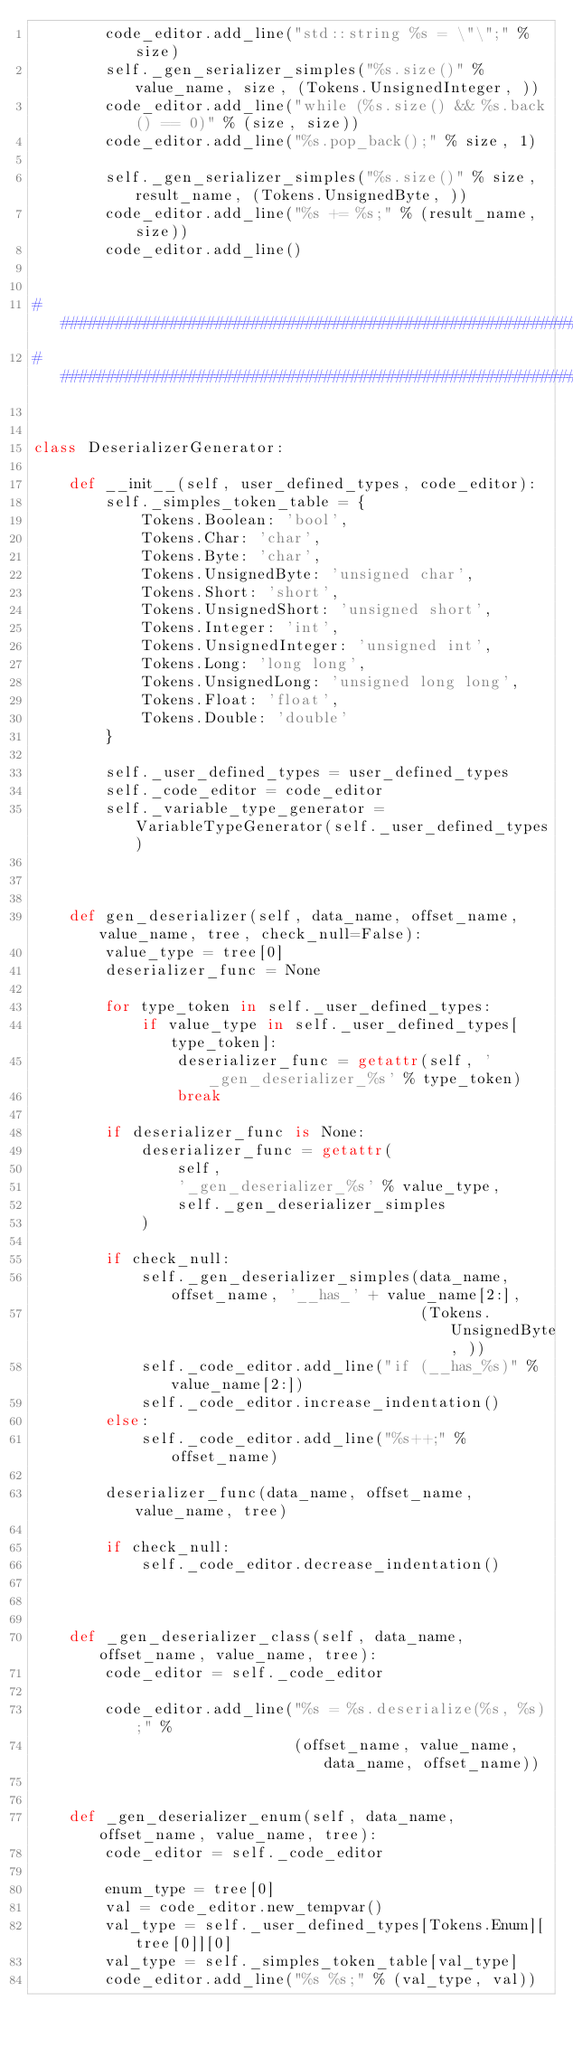<code> <loc_0><loc_0><loc_500><loc_500><_Python_>        code_editor.add_line("std::string %s = \"\";" % size)
        self._gen_serializer_simples("%s.size()" % value_name, size, (Tokens.UnsignedInteger, ))
        code_editor.add_line("while (%s.size() && %s.back() == 0)" % (size, size))
        code_editor.add_line("%s.pop_back();" % size, 1)

        self._gen_serializer_simples("%s.size()" % size, result_name, (Tokens.UnsignedByte, ))
        code_editor.add_line("%s += %s;" % (result_name, size))
        code_editor.add_line()


###################################################################################
###################################################################################


class DeserializerGenerator:

    def __init__(self, user_defined_types, code_editor):
        self._simples_token_table = {
            Tokens.Boolean: 'bool',
            Tokens.Char: 'char',
            Tokens.Byte: 'char',
            Tokens.UnsignedByte: 'unsigned char',
            Tokens.Short: 'short',
            Tokens.UnsignedShort: 'unsigned short',
            Tokens.Integer: 'int',
            Tokens.UnsignedInteger: 'unsigned int',
            Tokens.Long: 'long long',
            Tokens.UnsignedLong: 'unsigned long long',
            Tokens.Float: 'float',
            Tokens.Double: 'double'
        }

        self._user_defined_types = user_defined_types
        self._code_editor = code_editor
        self._variable_type_generator = VariableTypeGenerator(self._user_defined_types)



    def gen_deserializer(self, data_name, offset_name, value_name, tree, check_null=False):
        value_type = tree[0]
        deserializer_func = None

        for type_token in self._user_defined_types:
            if value_type in self._user_defined_types[type_token]:
                deserializer_func = getattr(self, '_gen_deserializer_%s' % type_token)
                break

        if deserializer_func is None:
            deserializer_func = getattr(
                self,
                '_gen_deserializer_%s' % value_type,
                self._gen_deserializer_simples
            )

        if check_null:
            self._gen_deserializer_simples(data_name, offset_name, '__has_' + value_name[2:], 
                                           (Tokens.UnsignedByte, ))
            self._code_editor.add_line("if (__has_%s)" % value_name[2:])
            self._code_editor.increase_indentation()
        else:
            self._code_editor.add_line("%s++;" % offset_name)

        deserializer_func(data_name, offset_name, value_name, tree)

        if check_null:
            self._code_editor.decrease_indentation()



    def _gen_deserializer_class(self, data_name, offset_name, value_name, tree):
        code_editor = self._code_editor

        code_editor.add_line("%s = %s.deserialize(%s, %s);" % 
                             (offset_name, value_name, data_name, offset_name))


    def _gen_deserializer_enum(self, data_name, offset_name, value_name, tree):
        code_editor = self._code_editor

        enum_type = tree[0]
        val = code_editor.new_tempvar()
        val_type = self._user_defined_types[Tokens.Enum][tree[0]][0]
        val_type = self._simples_token_table[val_type]
        code_editor.add_line("%s %s;" % (val_type, val))
</code> 